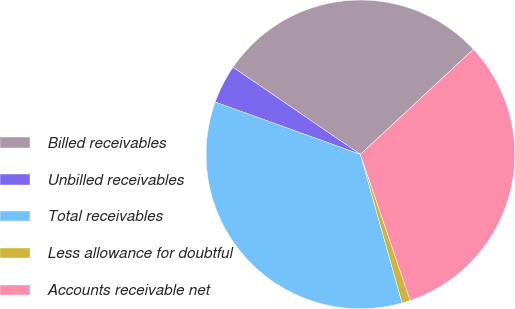<chart> <loc_0><loc_0><loc_500><loc_500><pie_chart><fcel>Billed receivables<fcel>Unbilled receivables<fcel>Total receivables<fcel>Less allowance for doubtful<fcel>Accounts receivable net<nl><fcel>28.53%<fcel>4.04%<fcel>34.85%<fcel>0.88%<fcel>31.69%<nl></chart> 